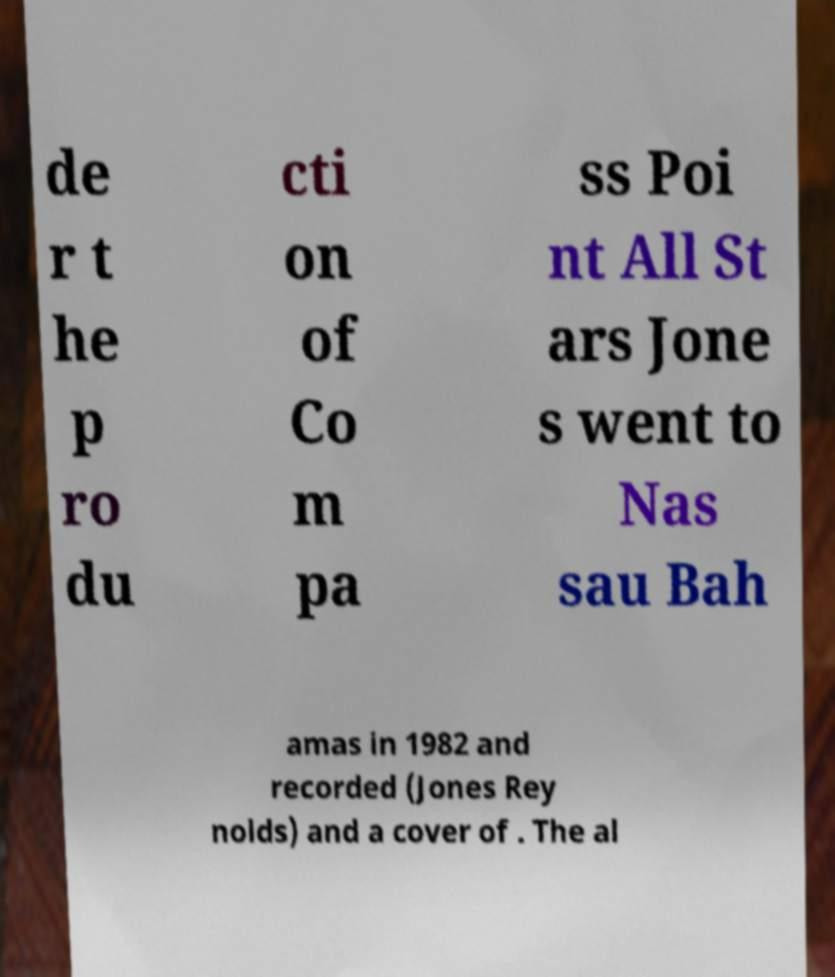For documentation purposes, I need the text within this image transcribed. Could you provide that? de r t he p ro du cti on of Co m pa ss Poi nt All St ars Jone s went to Nas sau Bah amas in 1982 and recorded (Jones Rey nolds) and a cover of . The al 